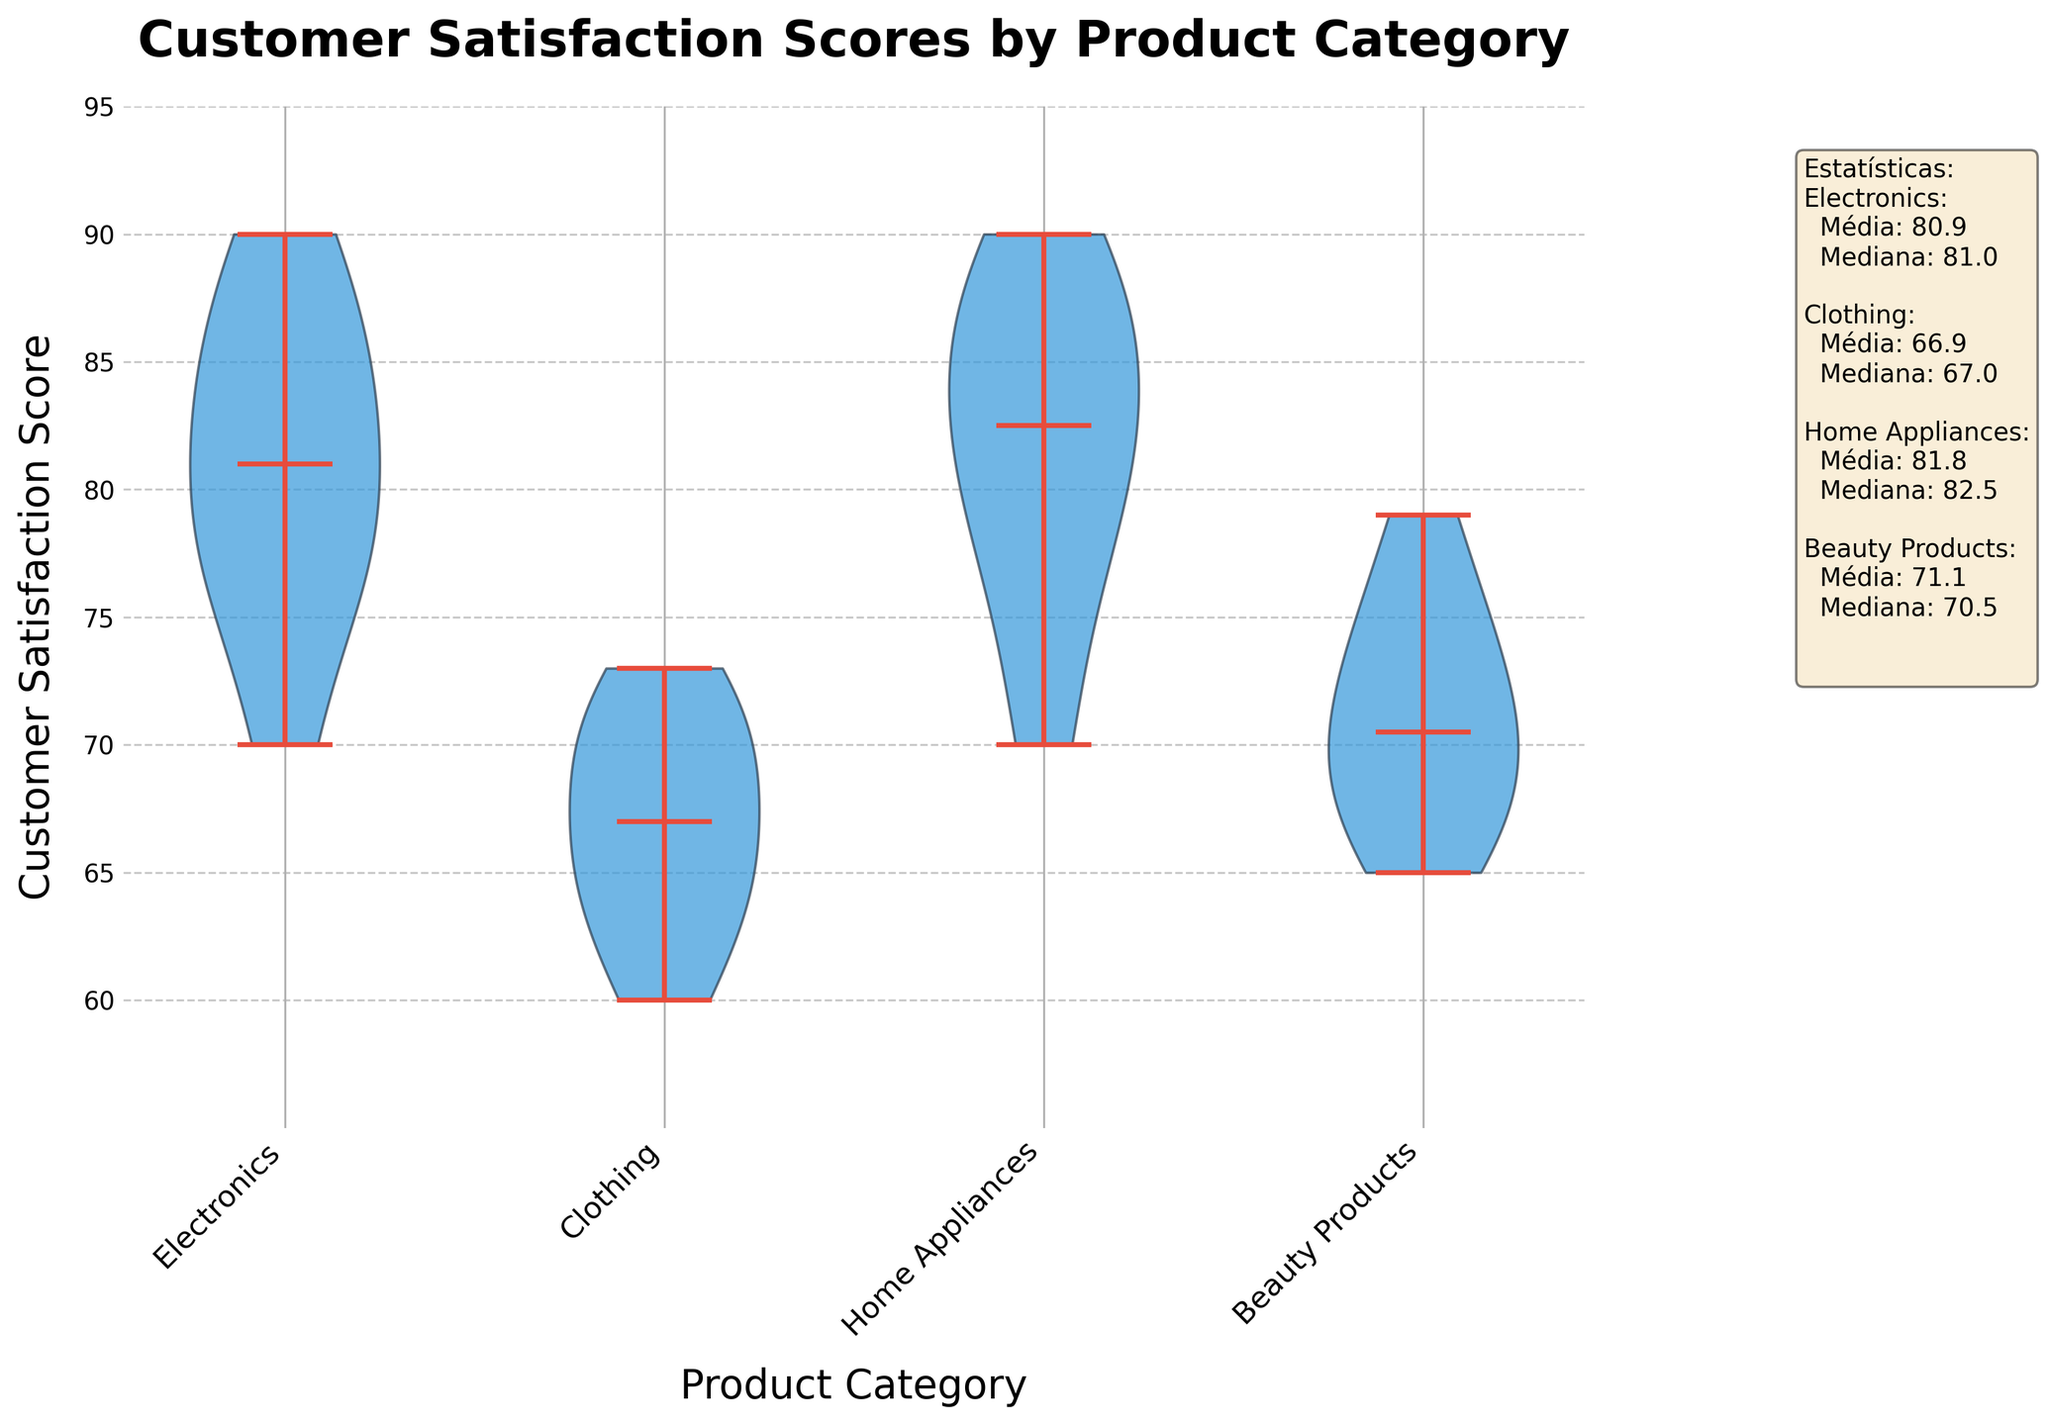What is the title of the chart? The title of the chart is written at the top of the figure and indicates the main subject of the visual representation.
Answer: Customer Satisfaction Scores by Product Category What is the range of Customer Satisfaction Scores for Electronics? The range of Customer Satisfaction Scores for Electronics can be observed from the lowest point to the highest point of the violin shape corresponding to Electronics.
Answer: 70 to 90 What is the median Customer Satisfaction Score for Clothing? The median value is represented by a line in the middle of the violin for the Clothing category.
Answer: 68 Which product category has the highest mean Customer Satisfaction Score? The mean score is presented in the statistics text box and needs comparison among categories to determine the highest one.
Answer: Home Appliances How does the variability in satisfaction scores compare between Electronics and Beauty Products? The width of the violin plot indicates the density and variability of the data. Compare the widths of the violins for Electronics and Beauty Products to assess their variability.
Answer: Electronics has higher variability Which category has the smallest range of Customer Satisfaction Scores? The range of scores for each category is indicated by the length of the violins from the minimum to the maximum score.
Answer: Clothing Are Customer Satisfaction Scores for Home Appliances generally higher or lower than Electronics? By comparing the positions of the violins for Home Appliances and Electronics along the y-axis, we can tell which category has generally higher scores.
Answer: Higher What is the y-axis range set for this violin plot? The y-axis range can be determined from the tick marks along the y-axis.
Answer: 55 to 95 Which category's Customer Satisfaction Scores are most tightly clustered around the median? The clustering around the median can be assessed by the density near the median line in the violin plot.
Answer: Clothing How do the medians of Beauty Products and Electronics compare? Compare the positions of the median lines within the violin plots for Beauty Products and Electronics.
Answer: Electronics has a higher median 